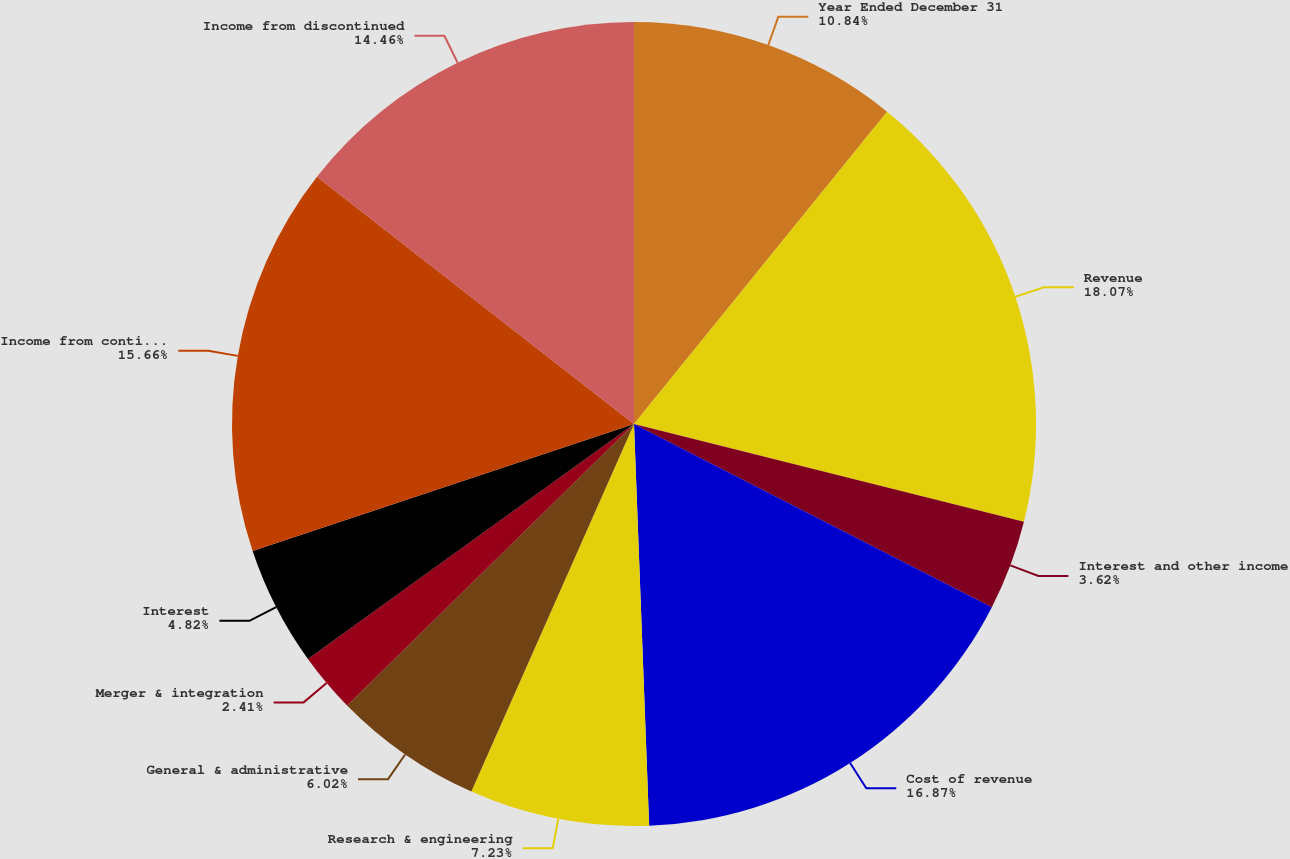<chart> <loc_0><loc_0><loc_500><loc_500><pie_chart><fcel>Year Ended December 31<fcel>Revenue<fcel>Interest and other income<fcel>Cost of revenue<fcel>Research & engineering<fcel>General & administrative<fcel>Merger & integration<fcel>Interest<fcel>Income from continuing<fcel>Income from discontinued<nl><fcel>10.84%<fcel>18.07%<fcel>3.62%<fcel>16.87%<fcel>7.23%<fcel>6.02%<fcel>2.41%<fcel>4.82%<fcel>15.66%<fcel>14.46%<nl></chart> 